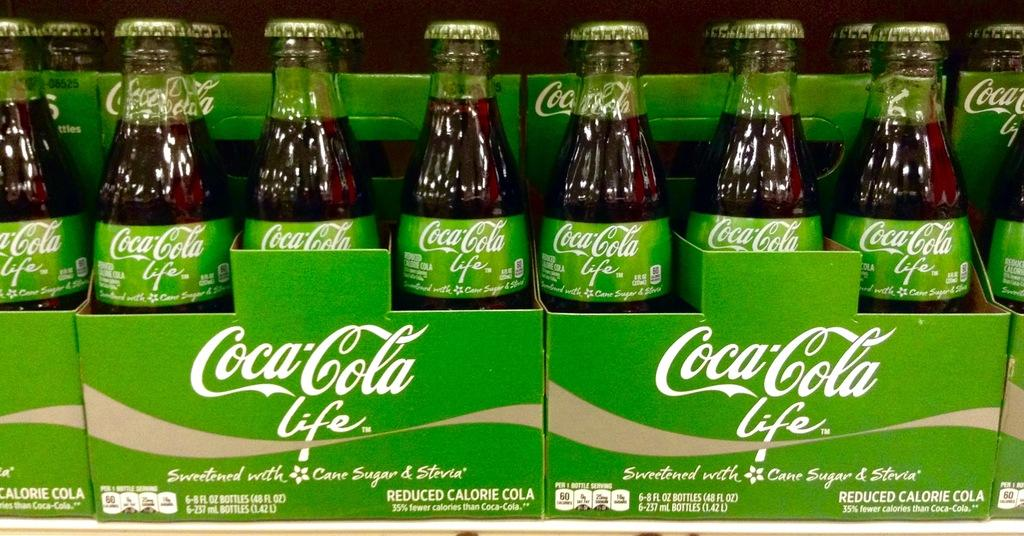Provide a one-sentence caption for the provided image. Several bottles of Coca Cola sitting side by side in cardboard containers. 